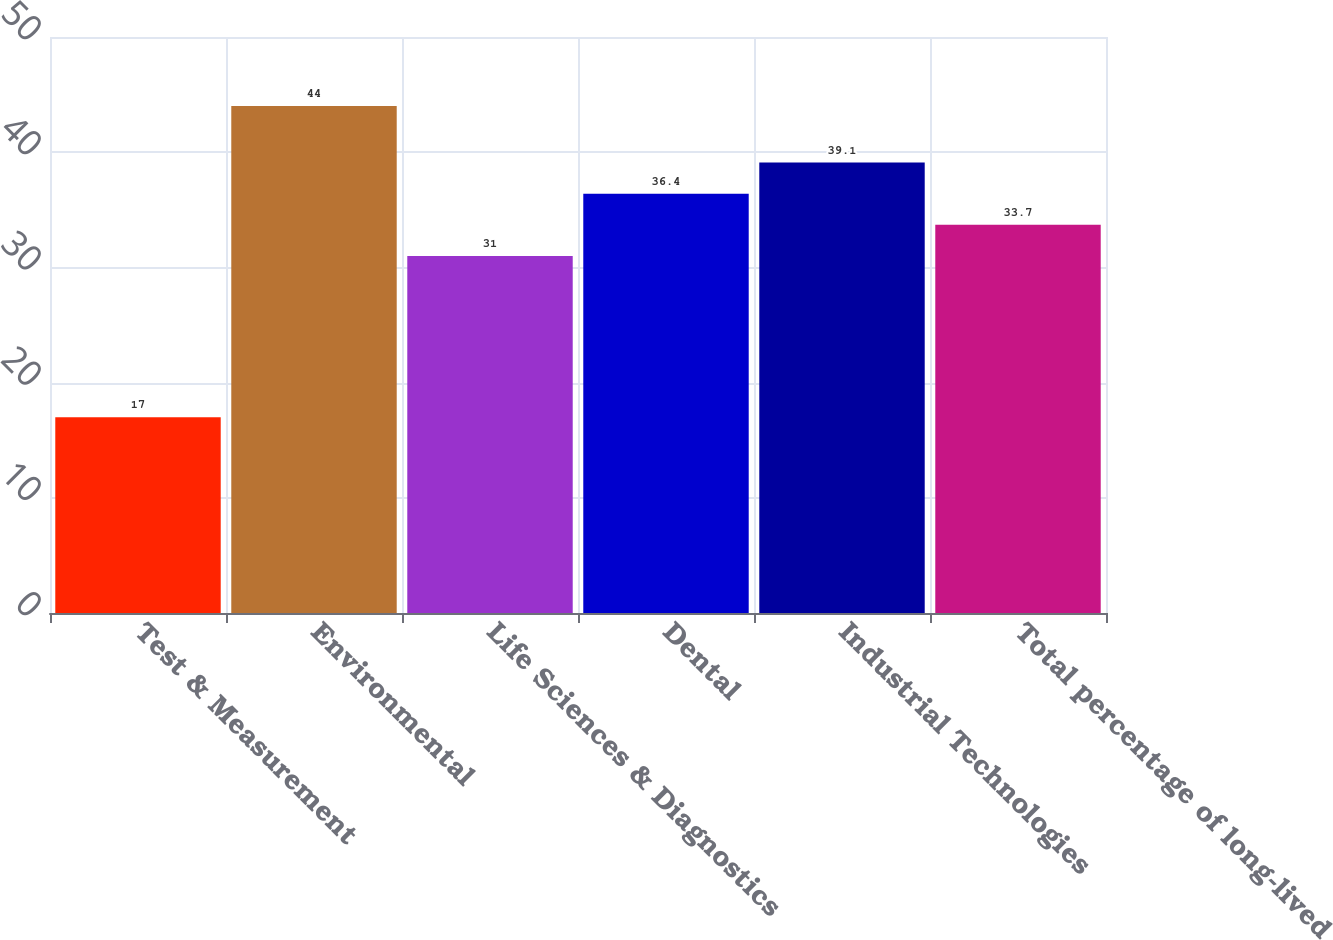Convert chart. <chart><loc_0><loc_0><loc_500><loc_500><bar_chart><fcel>Test & Measurement<fcel>Environmental<fcel>Life Sciences & Diagnostics<fcel>Dental<fcel>Industrial Technologies<fcel>Total percentage of long-lived<nl><fcel>17<fcel>44<fcel>31<fcel>36.4<fcel>39.1<fcel>33.7<nl></chart> 